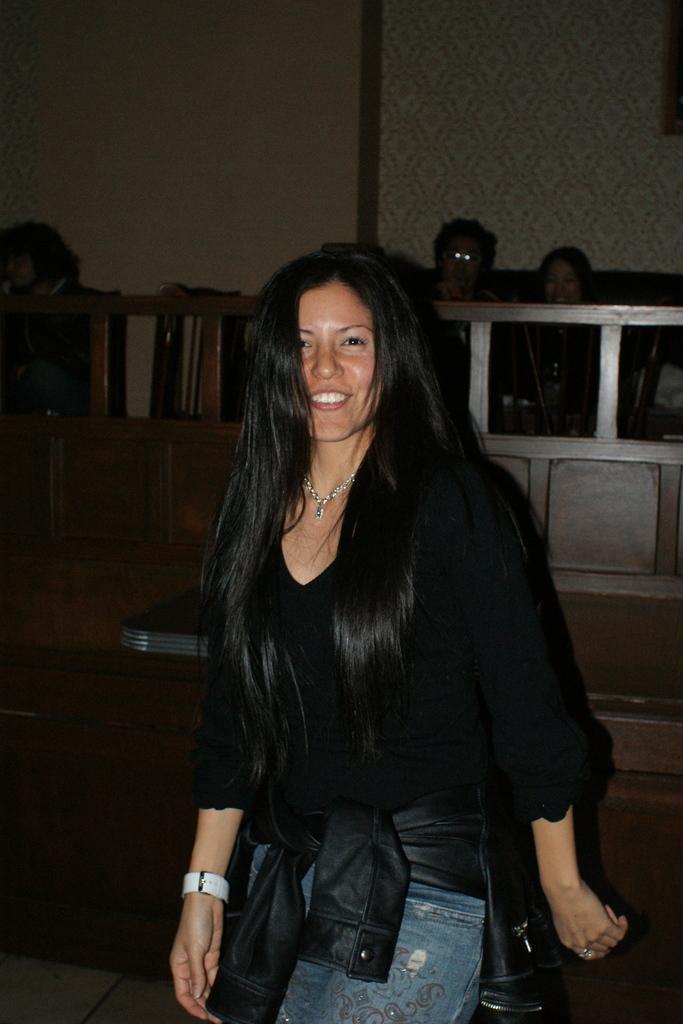How would you summarize this image in a sentence or two? In this picture we can see a woman, she is smiling, at the back of her we can see an object, fence and in the background we can see people, wall. 